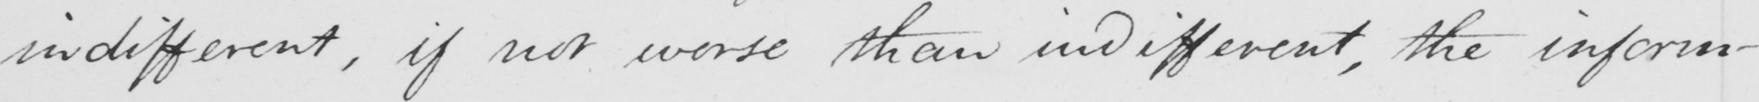Can you tell me what this handwritten text says? indifferent , if not worse than indifferent , the inform- 